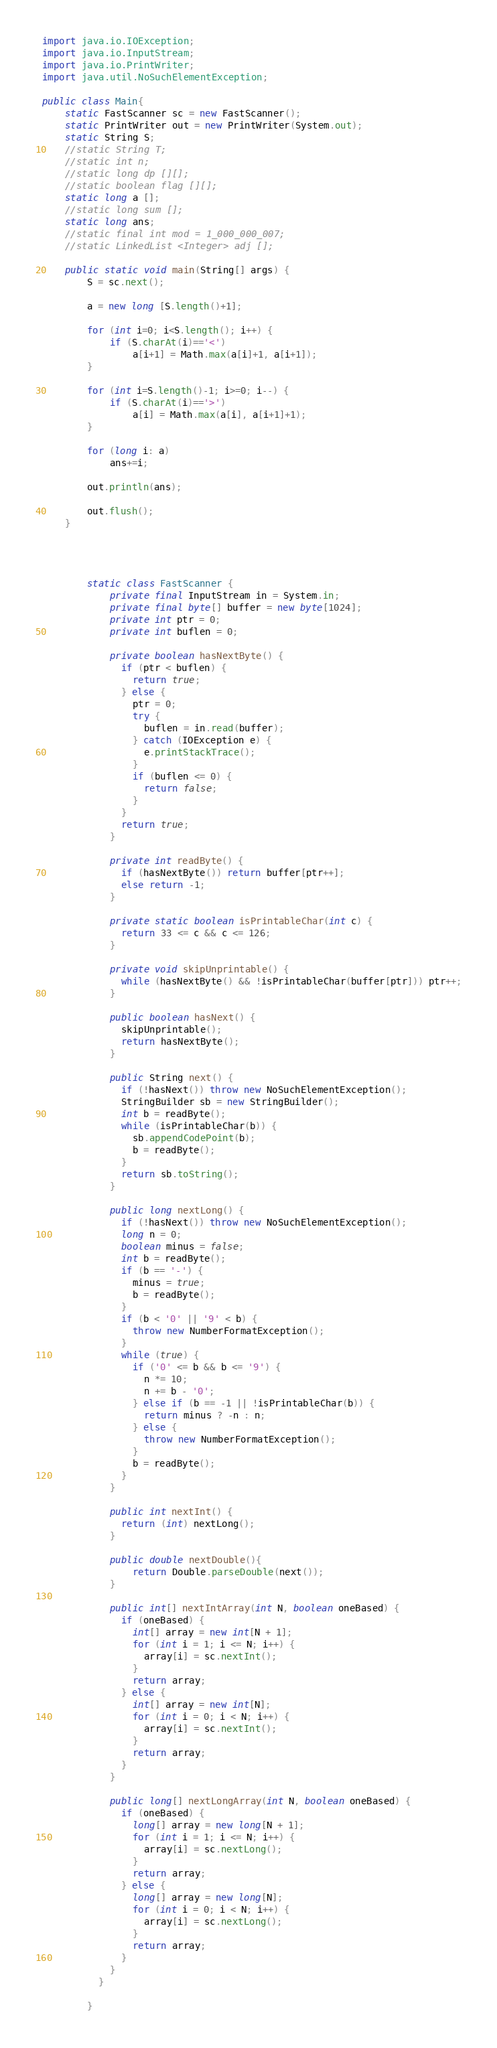Convert code to text. <code><loc_0><loc_0><loc_500><loc_500><_Java_>import java.io.IOException;
import java.io.InputStream;
import java.io.PrintWriter;
import java.util.NoSuchElementException;

public class Main{
	static FastScanner sc = new FastScanner();
	static PrintWriter out = new PrintWriter(System.out);
	static String S;
	//static String T;
	//static int n;
	//static long dp [][];
	//static boolean flag [][];
	static long a [];
	//static long sum [];
	static long ans;
	//static final int mod = 1_000_000_007;
	//static LinkedList <Integer> adj []; 
	
	public static void main(String[] args) {
		S = sc.next();
		
		a = new long [S.length()+1];
		
		for (int i=0; i<S.length(); i++) {
			if (S.charAt(i)=='<')
				a[i+1] = Math.max(a[i]+1, a[i+1]);
		}
		
		for (int i=S.length()-1; i>=0; i--) {
			if (S.charAt(i)=='>')
				a[i] = Math.max(a[i], a[i+1]+1);
		}
		
		for (long i: a)
			ans+=i;
		
		out.println(ans);
		
		out.flush();
	}
	
	
	
	
		static class FastScanner {
		    private final InputStream in = System.in;
		    private final byte[] buffer = new byte[1024];
		    private int ptr = 0;
		    private int buflen = 0;

		    private boolean hasNextByte() {
		      if (ptr < buflen) {
		        return true;
		      } else {
		        ptr = 0;
		        try {
		          buflen = in.read(buffer);
		        } catch (IOException e) {
		          e.printStackTrace();
		        }
		        if (buflen <= 0) {
		          return false;
		        }
		      }
		      return true;
		    }

		    private int readByte() {
		      if (hasNextByte()) return buffer[ptr++];
		      else return -1;
		    }

		    private static boolean isPrintableChar(int c) {
		      return 33 <= c && c <= 126;
		    }

		    private void skipUnprintable() {
		      while (hasNextByte() && !isPrintableChar(buffer[ptr])) ptr++;
		    }

		    public boolean hasNext() {
		      skipUnprintable();
		      return hasNextByte();
		    }

		    public String next() {
		      if (!hasNext()) throw new NoSuchElementException();
		      StringBuilder sb = new StringBuilder();
		      int b = readByte();
		      while (isPrintableChar(b)) {
		        sb.appendCodePoint(b);
		        b = readByte();
		      }
		      return sb.toString();
		    }

		    public long nextLong() {
		      if (!hasNext()) throw new NoSuchElementException();
		      long n = 0;
		      boolean minus = false;
		      int b = readByte();
		      if (b == '-') {
		        minus = true;
		        b = readByte();
		      }
		      if (b < '0' || '9' < b) {
		        throw new NumberFormatException();
		      }
		      while (true) {
		        if ('0' <= b && b <= '9') {
		          n *= 10;
		          n += b - '0';
		        } else if (b == -1 || !isPrintableChar(b)) {
		          return minus ? -n : n;
		        } else {
		          throw new NumberFormatException();
		        }
		        b = readByte();
		      }
		    }

		    public int nextInt() {
		      return (int) nextLong();
		    }
		    
		    public double nextDouble(){
		    	return Double.parseDouble(next());
		    }

		    public int[] nextIntArray(int N, boolean oneBased) {
		      if (oneBased) {
		        int[] array = new int[N + 1];
		        for (int i = 1; i <= N; i++) {
		          array[i] = sc.nextInt();
		        }
		        return array;
		      } else {
		        int[] array = new int[N];
		        for (int i = 0; i < N; i++) {
		          array[i] = sc.nextInt();
		        }
		        return array;
		      }
		    }

		    public long[] nextLongArray(int N, boolean oneBased) {
		      if (oneBased) {
		        long[] array = new long[N + 1];
		        for (int i = 1; i <= N; i++) {
		          array[i] = sc.nextLong();
		        }
		        return array;
		      } else {
		        long[] array = new long[N];
		        for (int i = 0; i < N; i++) {
		          array[i] = sc.nextLong();
		        }
		        return array;
		      }
		    }
		  }

		}	 



</code> 